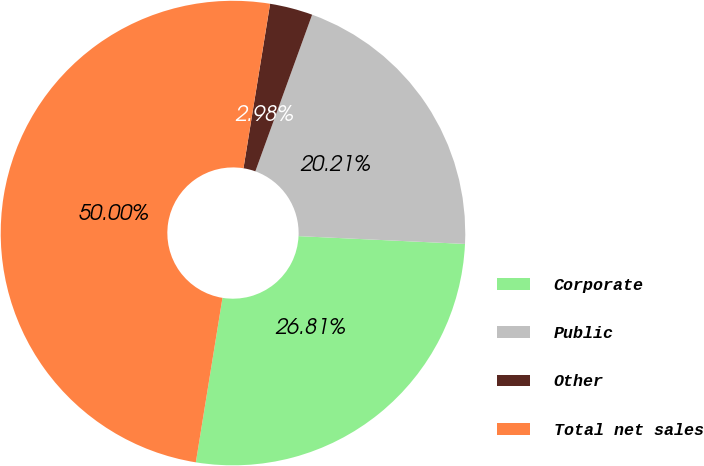Convert chart. <chart><loc_0><loc_0><loc_500><loc_500><pie_chart><fcel>Corporate<fcel>Public<fcel>Other<fcel>Total net sales<nl><fcel>26.81%<fcel>20.21%<fcel>2.98%<fcel>50.0%<nl></chart> 